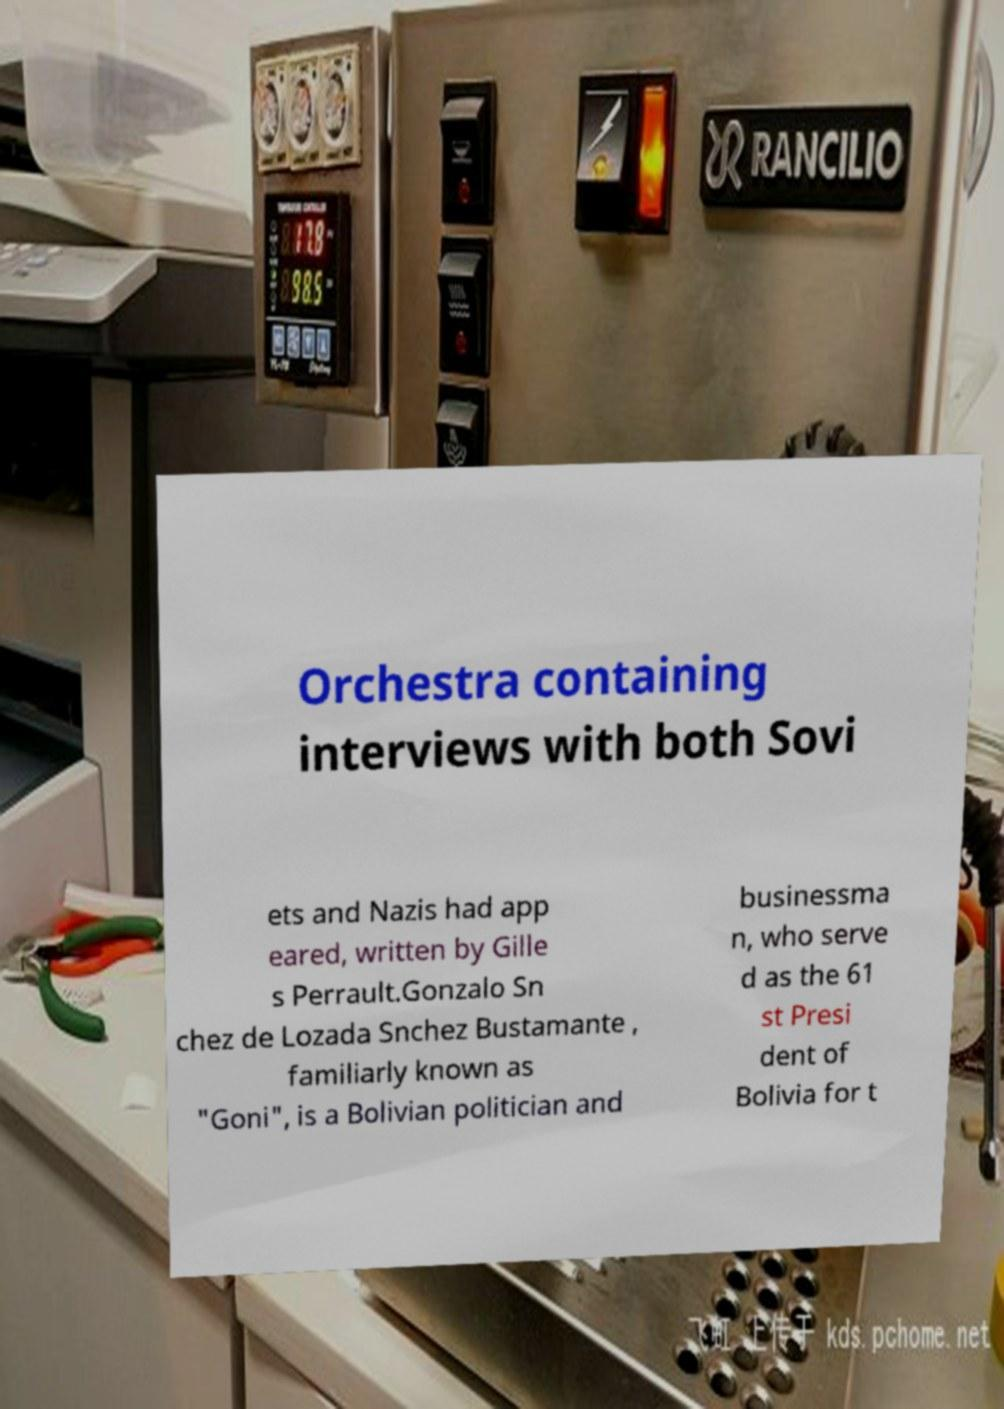I need the written content from this picture converted into text. Can you do that? Orchestra containing interviews with both Sovi ets and Nazis had app eared, written by Gille s Perrault.Gonzalo Sn chez de Lozada Snchez Bustamante , familiarly known as "Goni", is a Bolivian politician and businessma n, who serve d as the 61 st Presi dent of Bolivia for t 